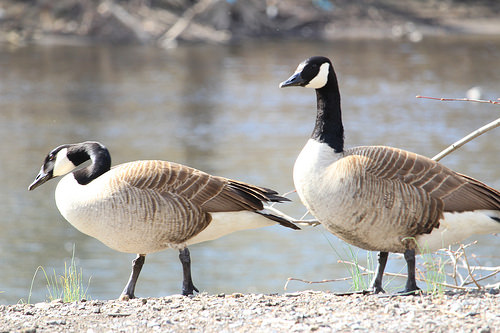<image>
Is there a goose in front of the water? Yes. The goose is positioned in front of the water, appearing closer to the camera viewpoint. 